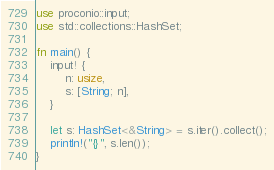Convert code to text. <code><loc_0><loc_0><loc_500><loc_500><_Rust_>use proconio::input;
use std::collections::HashSet;

fn main() {
    input! {
        n: usize,
        s: [String; n],
    }

    let s: HashSet<&String> = s.iter().collect();
    println!("{}", s.len());
}
</code> 